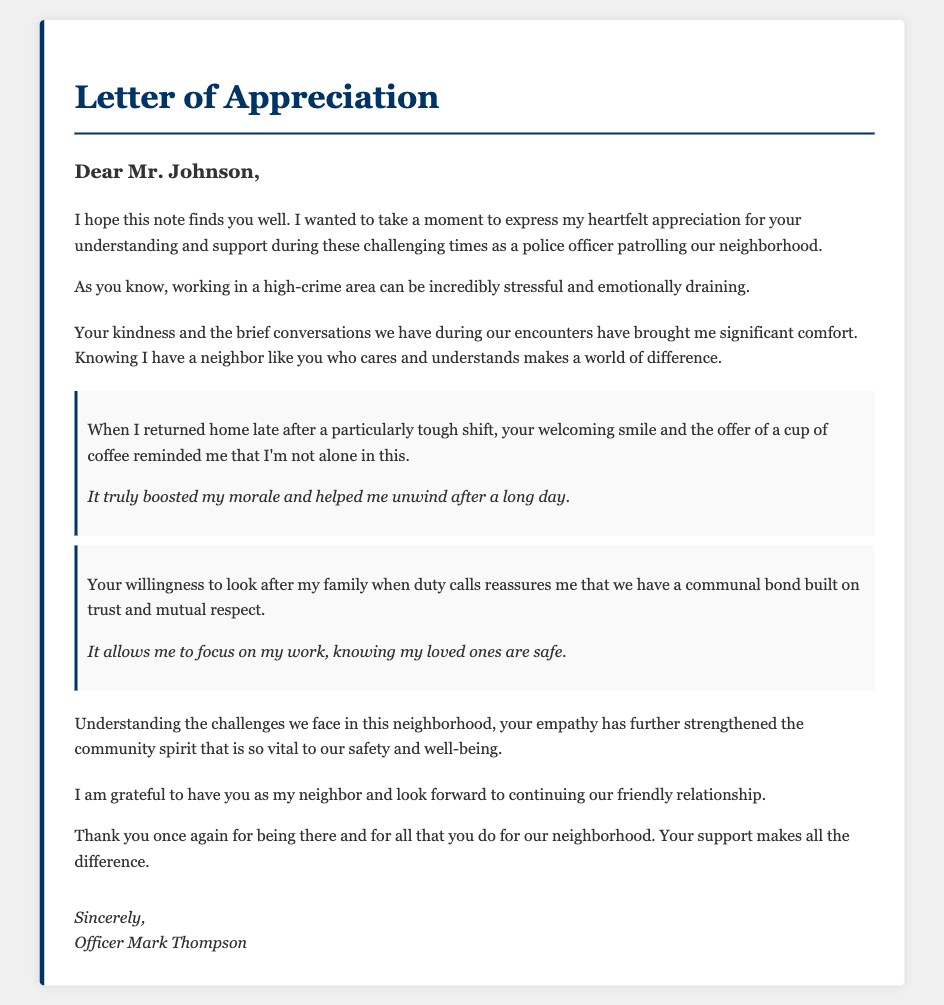What is the title of the document? The title appears in the header section of the document.
Answer: Letter of Appreciation Who is the letter addressed to? The greeting section mentions the recipient's name.
Answer: Mr. Johnson What is the author’s name? The signature section provides the name of the writer.
Answer: Officer Mark Thompson What has been emphasized as a source of comfort for the officer? The officer expresses gratitude for certain interactions in the document.
Answer: Brief conversations What did the neighbor offer the officer after a tough shift? An example in the document describes a specific comforting offer.
Answer: A cup of coffee How does the officer feel about their relationship with the neighbor? The officer expresses a sentiment regarding their neighbor in the closing section.
Answer: Grateful What two qualities does the officer mention about the bond with the neighbor? The document highlights specific aspects of the relationship.
Answer: Trust and mutual respect What type of area does the officer patrol? The officer describes the nature of their work environment.
Answer: High-crime area What does the letter aim to acknowledge? The main purpose of the letter is conveyed through expressions of sentiment.
Answer: Understanding and support 